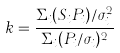Convert formula to latex. <formula><loc_0><loc_0><loc_500><loc_500>k = \frac { \Sigma _ { i } ( S _ { i } P _ { i } ) / \sigma _ { i } ^ { 2 } } { \Sigma _ { i } ( P _ { i } / \sigma _ { i } ) ^ { 2 } }</formula> 